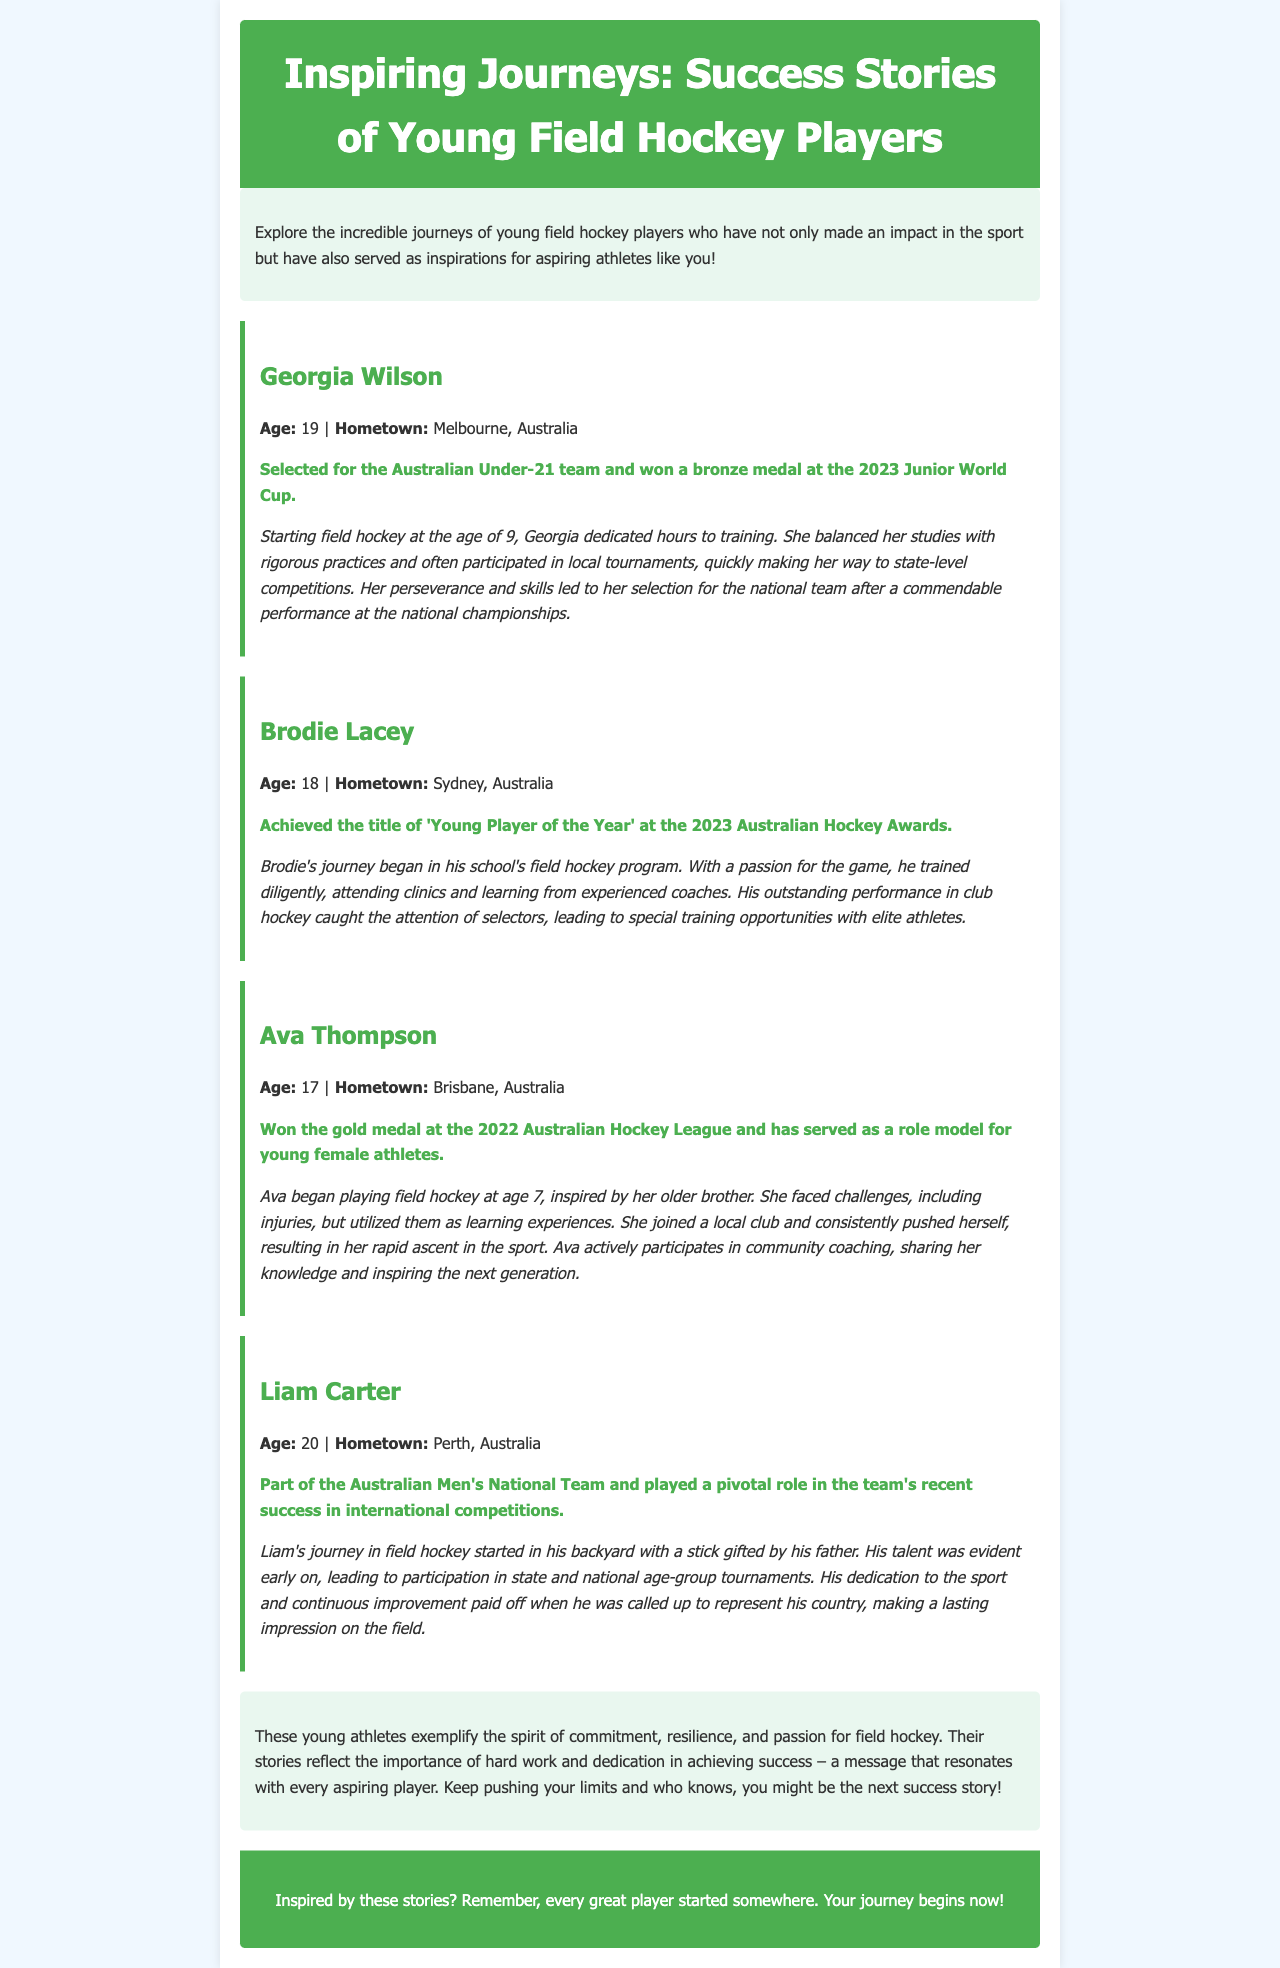What is Georgia Wilson's age? Georgia Wilson is mentioned in the document with her age listed as part of her profile.
Answer: 19 Which medal did Georgia Wilson win at the 2023 Junior World Cup? The document states that Georgia Wilson won a bronze medal at the 2023 Junior World Cup.
Answer: Bronze What is Brodie Lacey's hometown? Brodie Lacey's hometown is provided in his profile within the newsletter.
Answer: Sydney What achievement did Ava Thompson accomplish in 2022? Ava Thompson's achievement in 2022 is highlighted in the document, noting her winning a specific medal.
Answer: Gold medal at the 2022 Australian Hockey League What pivotal role did Liam Carter play in the Australian Men's National Team? The document indicates that Liam Carter played a significant role in the team's recent success in international competitions.
Answer: Pivotal role How did Ava Thompson respond to injuries in her career? The document mentions how Ava Thompson viewed her challenges, specifically regarding injuries, and how she used them.
Answer: Learning experiences What can aspiring players learn from the success stories mentioned? The conclusion of the document summarizes a key lesson to be learned from the success stories.
Answer: Commitment, resilience, and passion What relationship inspired Ava Thompson to start playing field hockey? The document explains Ava Thompson's inspiration for taking up the sport.
Answer: Her older brother What was Brodie Lacey's initial introduction to field hockey? The document describes that Brodie Lacey's journey began in his school's field hockey program.
Answer: School's field hockey program 